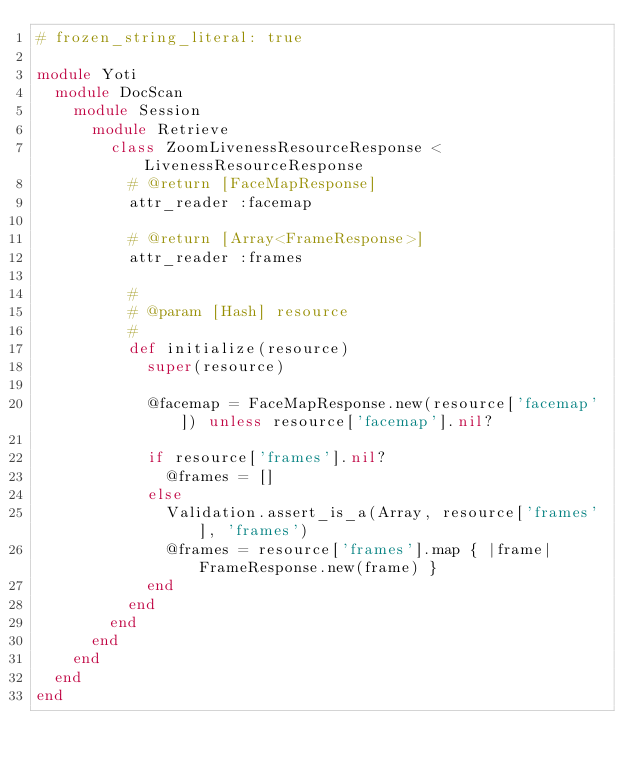<code> <loc_0><loc_0><loc_500><loc_500><_Ruby_># frozen_string_literal: true

module Yoti
  module DocScan
    module Session
      module Retrieve
        class ZoomLivenessResourceResponse < LivenessResourceResponse
          # @return [FaceMapResponse]
          attr_reader :facemap

          # @return [Array<FrameResponse>]
          attr_reader :frames

          #
          # @param [Hash] resource
          #
          def initialize(resource)
            super(resource)

            @facemap = FaceMapResponse.new(resource['facemap']) unless resource['facemap'].nil?

            if resource['frames'].nil?
              @frames = []
            else
              Validation.assert_is_a(Array, resource['frames'], 'frames')
              @frames = resource['frames'].map { |frame| FrameResponse.new(frame) }
            end
          end
        end
      end
    end
  end
end
</code> 